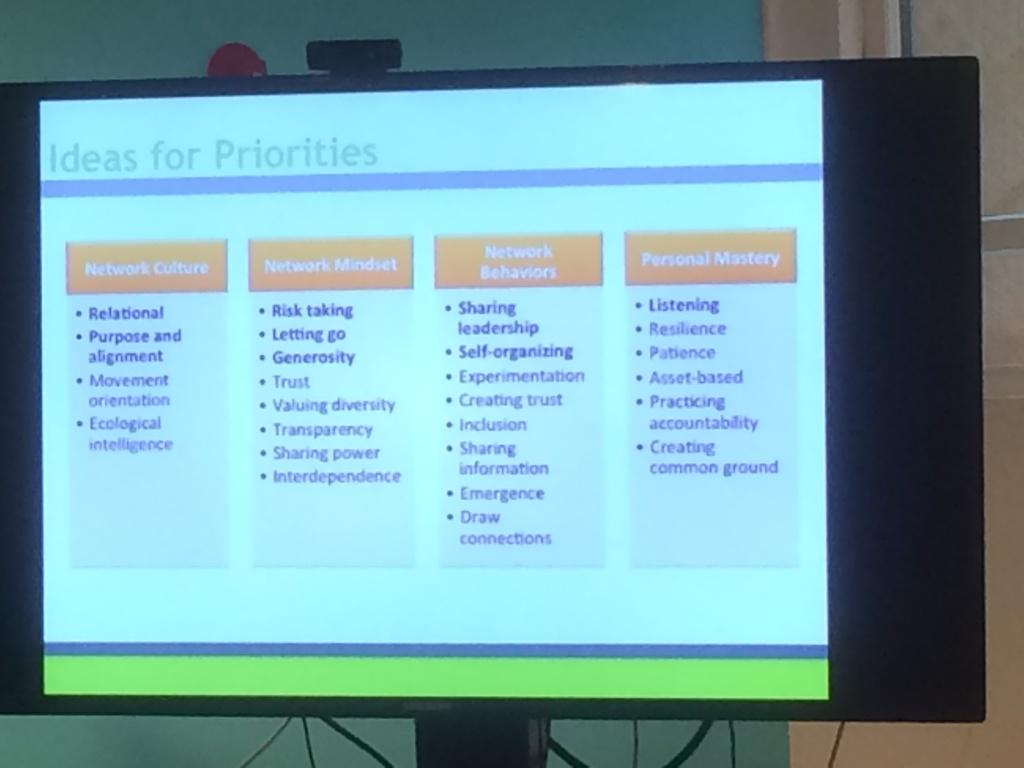<image>
Share a concise interpretation of the image provided. A computer monitor dispays ideas for priorities on screen. 